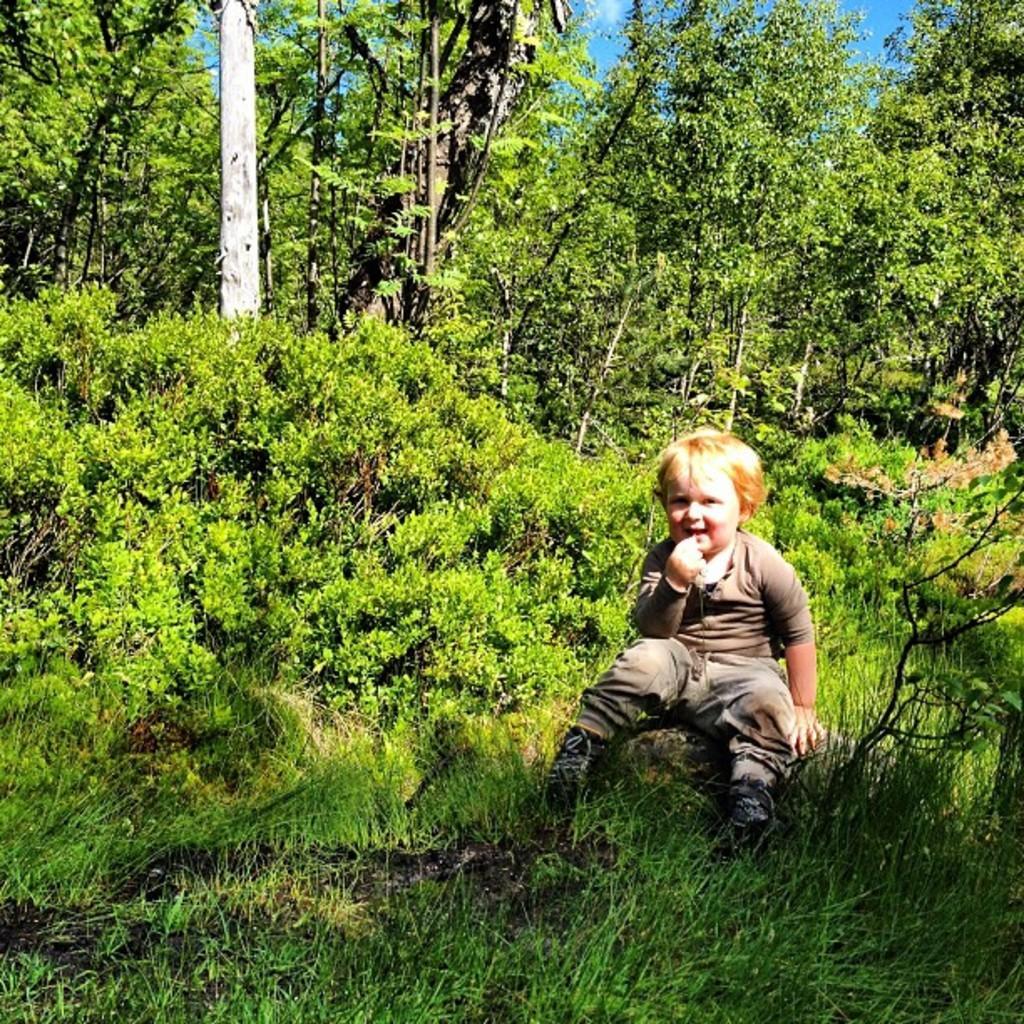In one or two sentences, can you explain what this image depicts? This image is taken outdoors. At the top of the image there is a sky with clouds. In the middle of the image a kid is sitting on the rock. At the bottom of the image there is a ground with grass on it. In this image there are many trees and plants with leaves, stems and branches. 